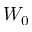<formula> <loc_0><loc_0><loc_500><loc_500>W _ { 0 }</formula> 